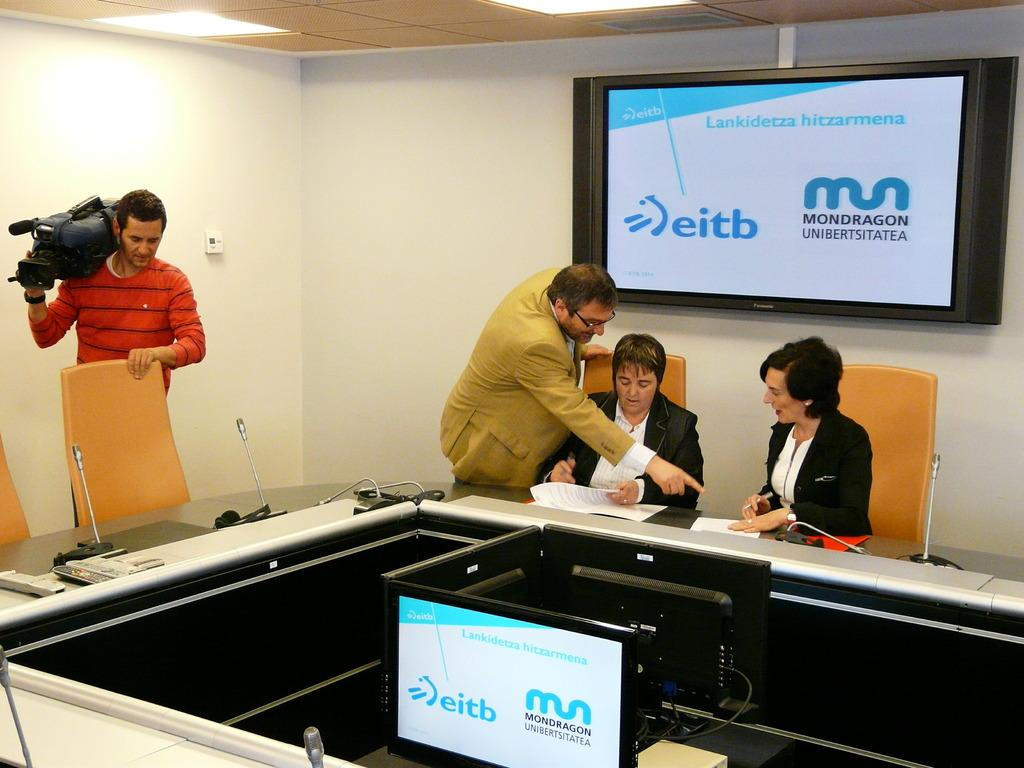Provide a one-sentence caption for the provided image. Two men and two women are working in meeting room for Mondragon. 